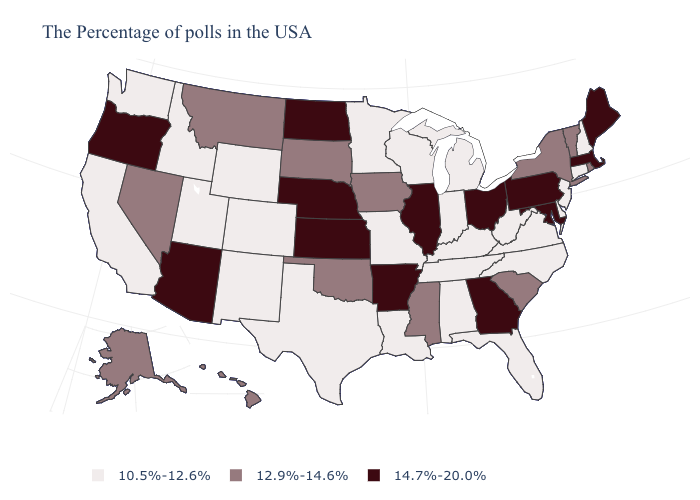What is the value of Ohio?
Give a very brief answer. 14.7%-20.0%. What is the value of Iowa?
Answer briefly. 12.9%-14.6%. Does Kansas have the highest value in the USA?
Short answer required. Yes. Does Maryland have the highest value in the USA?
Write a very short answer. Yes. What is the highest value in the USA?
Short answer required. 14.7%-20.0%. Does South Dakota have the highest value in the MidWest?
Answer briefly. No. What is the highest value in states that border Oregon?
Write a very short answer. 12.9%-14.6%. Does New Hampshire have a higher value than Louisiana?
Be succinct. No. Among the states that border Florida , which have the highest value?
Quick response, please. Georgia. What is the highest value in the West ?
Write a very short answer. 14.7%-20.0%. How many symbols are there in the legend?
Be succinct. 3. Which states have the highest value in the USA?
Short answer required. Maine, Massachusetts, Maryland, Pennsylvania, Ohio, Georgia, Illinois, Arkansas, Kansas, Nebraska, North Dakota, Arizona, Oregon. Among the states that border Wyoming , does Colorado have the lowest value?
Keep it brief. Yes. Name the states that have a value in the range 14.7%-20.0%?
Concise answer only. Maine, Massachusetts, Maryland, Pennsylvania, Ohio, Georgia, Illinois, Arkansas, Kansas, Nebraska, North Dakota, Arizona, Oregon. Does Kansas have the highest value in the MidWest?
Give a very brief answer. Yes. 